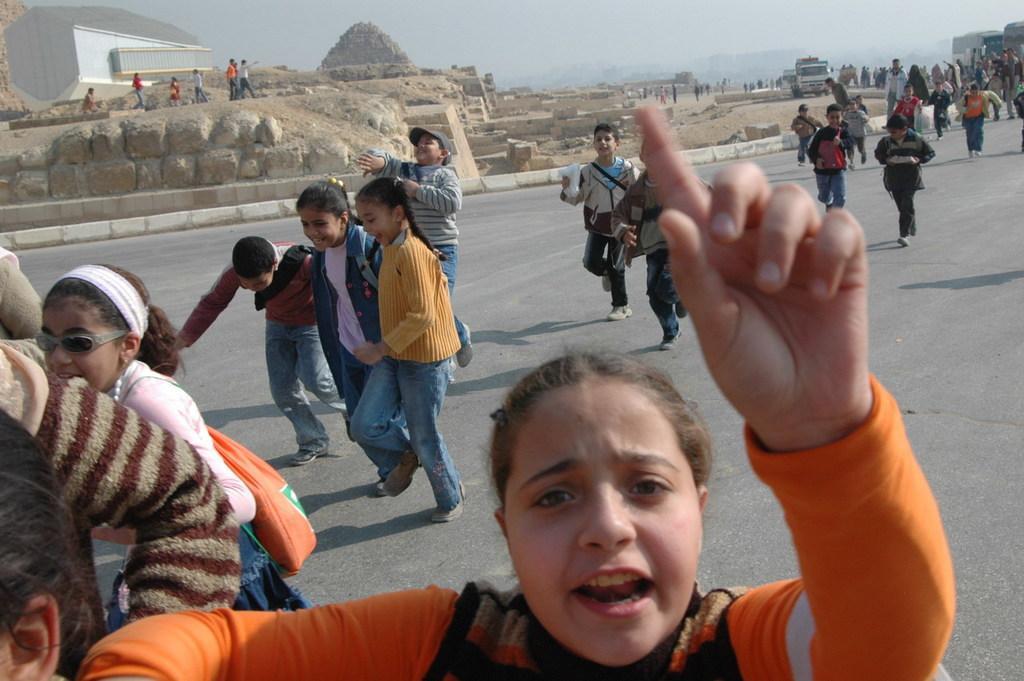Could you give a brief overview of what you see in this image? There are people and these kids are running on the road. In the background we can see wall, house, people, vehicles and sky. 